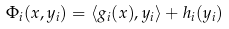<formula> <loc_0><loc_0><loc_500><loc_500>\Phi _ { i } ( x , y _ { i } ) = \langle g _ { i } ( x ) , y _ { i } \rangle + h _ { i } ( y _ { i } )</formula> 